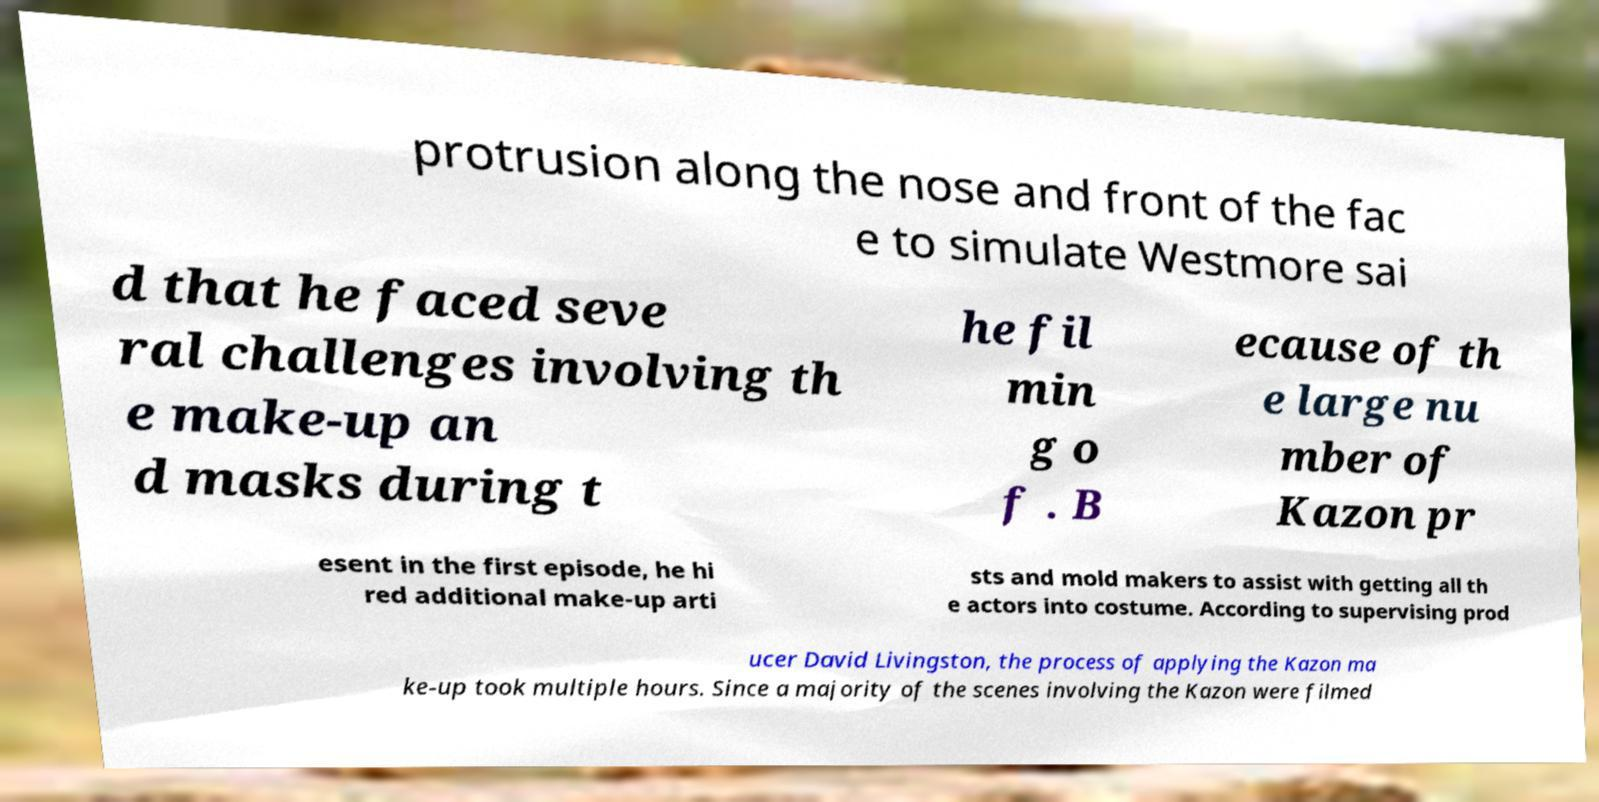Can you read and provide the text displayed in the image?This photo seems to have some interesting text. Can you extract and type it out for me? protrusion along the nose and front of the fac e to simulate Westmore sai d that he faced seve ral challenges involving th e make-up an d masks during t he fil min g o f . B ecause of th e large nu mber of Kazon pr esent in the first episode, he hi red additional make-up arti sts and mold makers to assist with getting all th e actors into costume. According to supervising prod ucer David Livingston, the process of applying the Kazon ma ke-up took multiple hours. Since a majority of the scenes involving the Kazon were filmed 